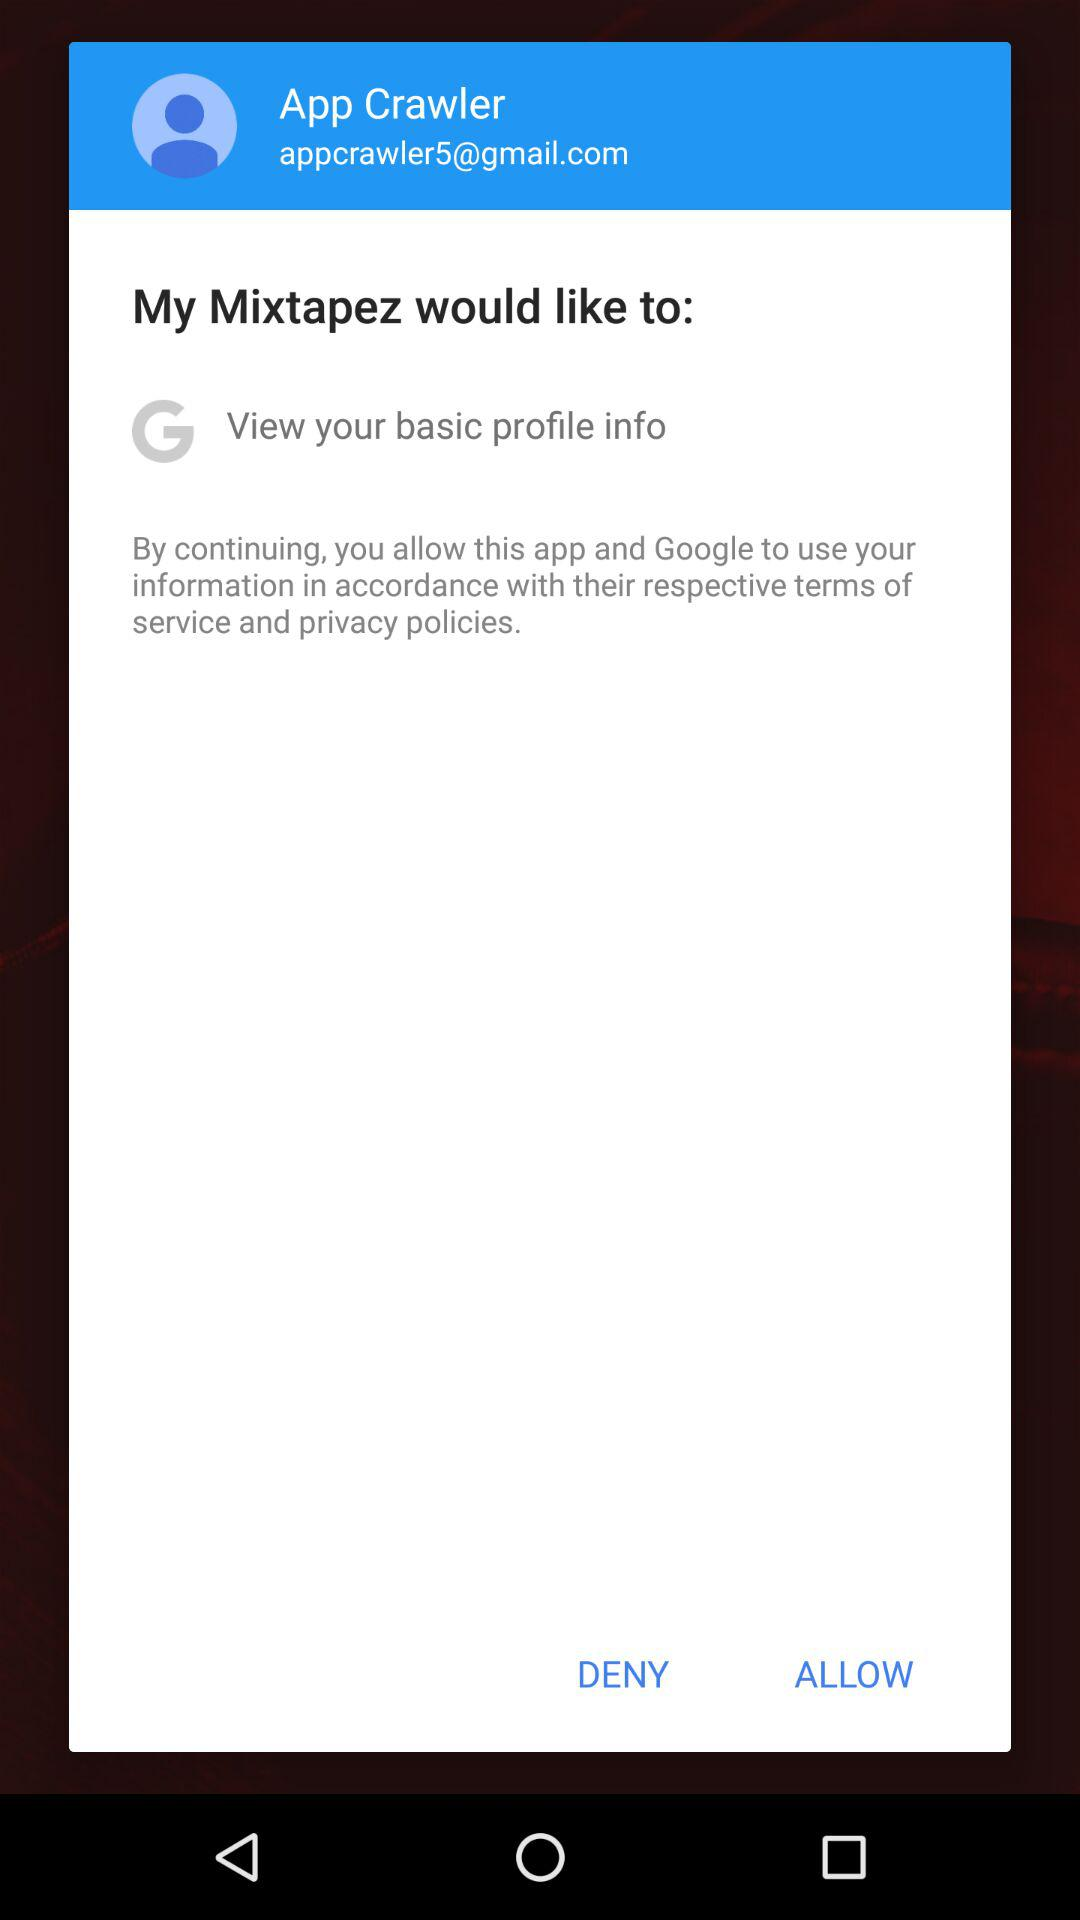Has the user agreed to the terms of service and privacy policy?
When the provided information is insufficient, respond with <no answer>. <no answer> 